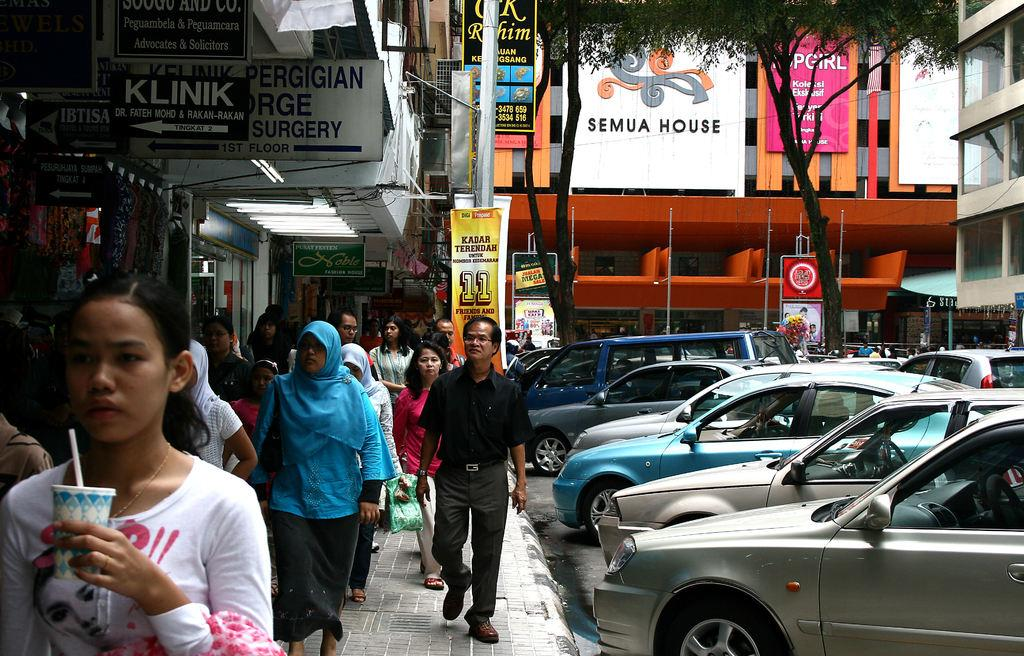<image>
Render a clear and concise summary of the photo. A crowded sidewalk of people and a banner hanging with Semua House on it is hanging in the background. 